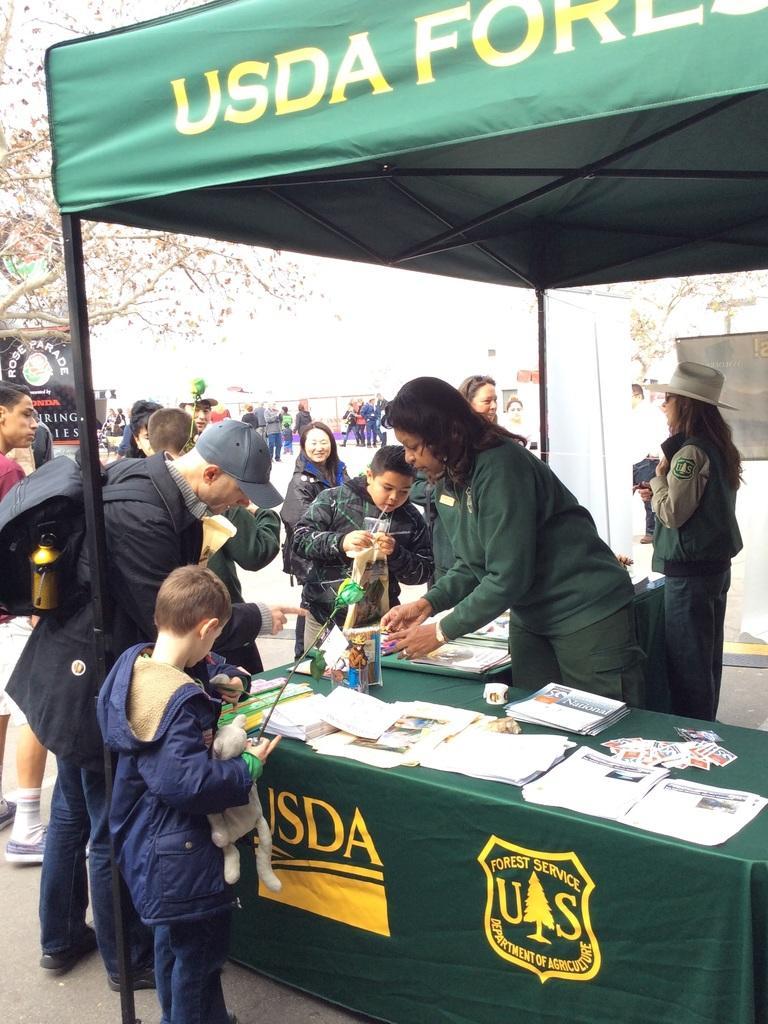In one or two sentences, can you explain what this image depicts? In this picture I can see a woman who is standing near to the table. On the table I can see the book, papers, stickers and other objects. In the bottom left there is a boy who is standing near to the pipe. Beside him I can see many people who are standing on the road. In the background I can see another group of person who are standing near to the fencing. In the background I can see the trees and sky. 